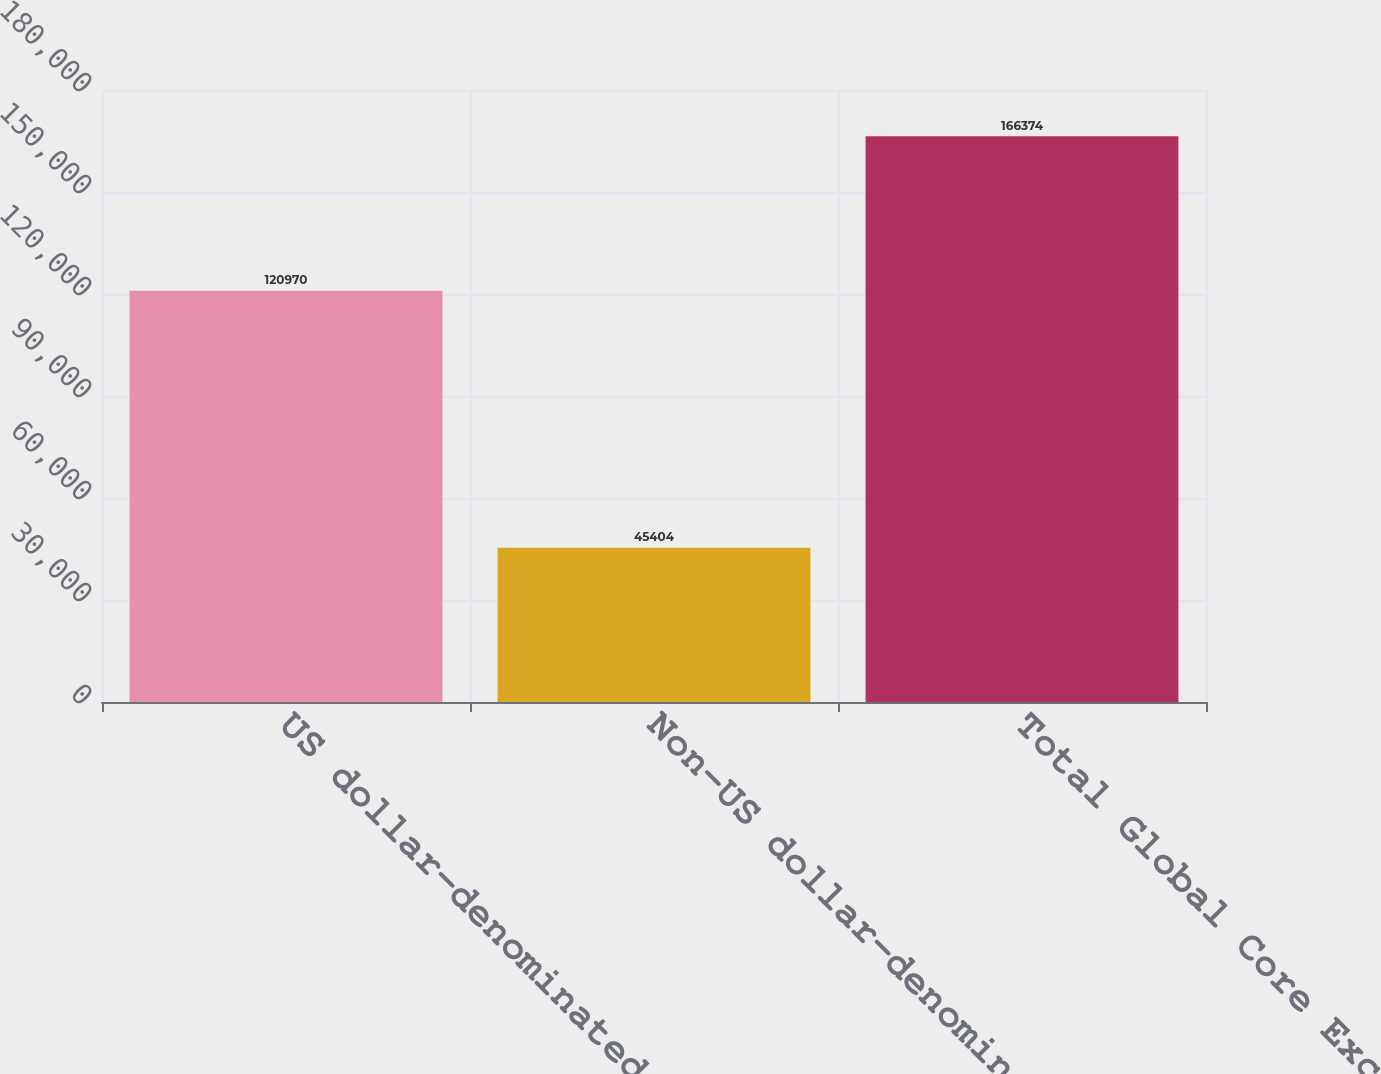Convert chart. <chart><loc_0><loc_0><loc_500><loc_500><bar_chart><fcel>US dollar-denominated<fcel>Non-US dollar-denominated<fcel>Total Global Core Excess<nl><fcel>120970<fcel>45404<fcel>166374<nl></chart> 